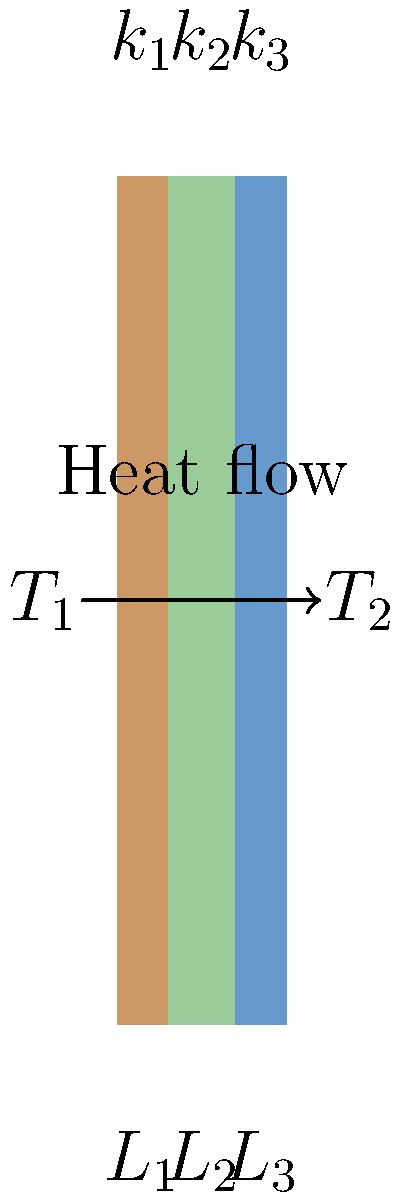As part of your research into natural remedies for dark spots, you've come across the importance of understanding heat transfer in skincare products. Consider a composite wall made of three layers with thermal conductivities $k_1$, $k_2$, and $k_3$, and thicknesses $L_1$, $L_2$, and $L_3$ respectively. The temperatures on the outer surfaces are $T_1$ and $T_2$. If the heat transfer rate through the wall is 500 W/m², what is the temperature difference $(T_1 - T_2)$ across the wall? Use the following values:

$k_1 = 0.5$ W/m·K, $k_2 = 0.3$ W/m·K, $k_3 = 0.2$ W/m·K
$L_1 = 0.02$ m, $L_2 = 0.03$ m, $L_3 = 0.01$ m To solve this problem, we'll use the concept of thermal resistance in series for a composite wall. Let's follow these steps:

1) The heat transfer rate $q$ is given by:
   $q = \frac{T_1 - T_2}{R_{total}}$

   where $R_{total}$ is the total thermal resistance of the wall.

2) For a composite wall, the total thermal resistance is the sum of individual layer resistances:
   $R_{total} = R_1 + R_2 + R_3$

3) The thermal resistance for each layer is given by:
   $R = \frac{L}{k}$

4) Calculate the resistance for each layer:
   $R_1 = \frac{L_1}{k_1} = \frac{0.02}{0.5} = 0.04$ m²·K/W
   $R_2 = \frac{L_2}{k_2} = \frac{0.03}{0.3} = 0.1$ m²·K/W
   $R_3 = \frac{L_3}{k_3} = \frac{0.01}{0.2} = 0.05$ m²·K/W

5) Calculate the total resistance:
   $R_{total} = 0.04 + 0.1 + 0.05 = 0.19$ m²·K/W

6) Now, we can rearrange the heat transfer equation to solve for $(T_1 - T_2)$:
   $T_1 - T_2 = q \cdot R_{total}$

7) Substitute the values:
   $T_1 - T_2 = 500 \cdot 0.19 = 95$ K

Therefore, the temperature difference across the wall is 95 K.
Answer: 95 K 